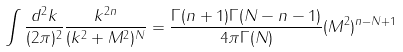<formula> <loc_0><loc_0><loc_500><loc_500>\int \frac { d ^ { 2 } k } { ( 2 \pi ) ^ { 2 } } \frac { k ^ { 2 n } } { ( k ^ { 2 } + M ^ { 2 } ) ^ { N } } = \frac { \Gamma ( n + 1 ) \Gamma ( N - n - 1 ) } { 4 \pi \Gamma ( N ) } ( M ^ { 2 } ) ^ { n - N + 1 } \,</formula> 